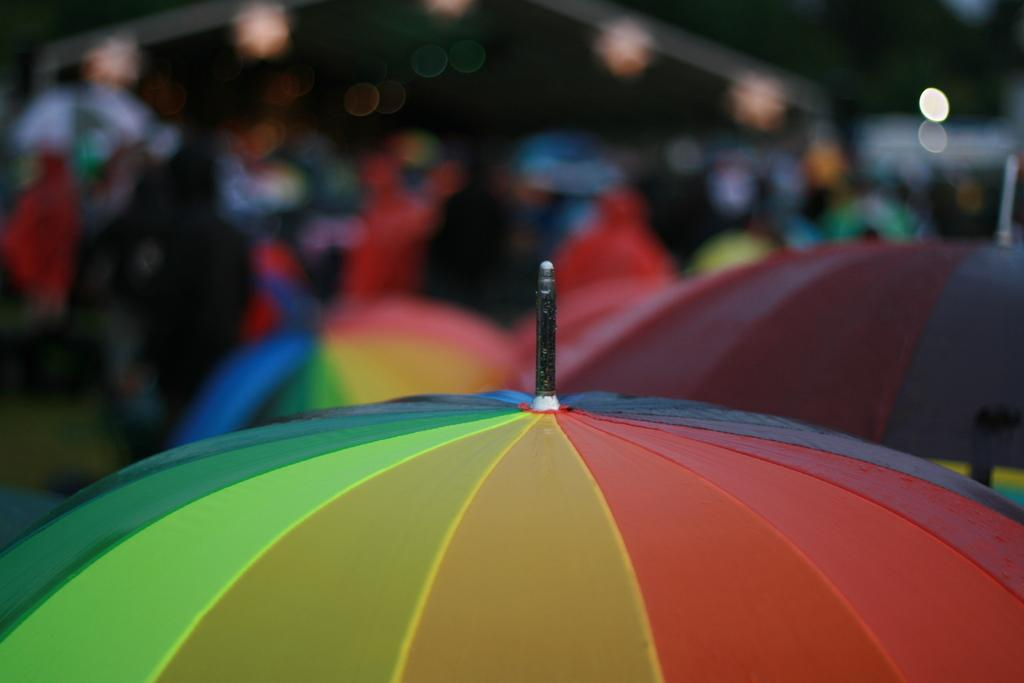What objects can be seen in the image? There are umbrellas in the image. Can you describe the background of the image? The background of the image is blurry. How many twigs are present in the image? There are no twigs present in the image; it only features umbrellas. What is the appropriate way to say good-bye to the umbrellas in the image? There is no need to say good-bye to the umbrellas in the image, as they are not sentient beings. 